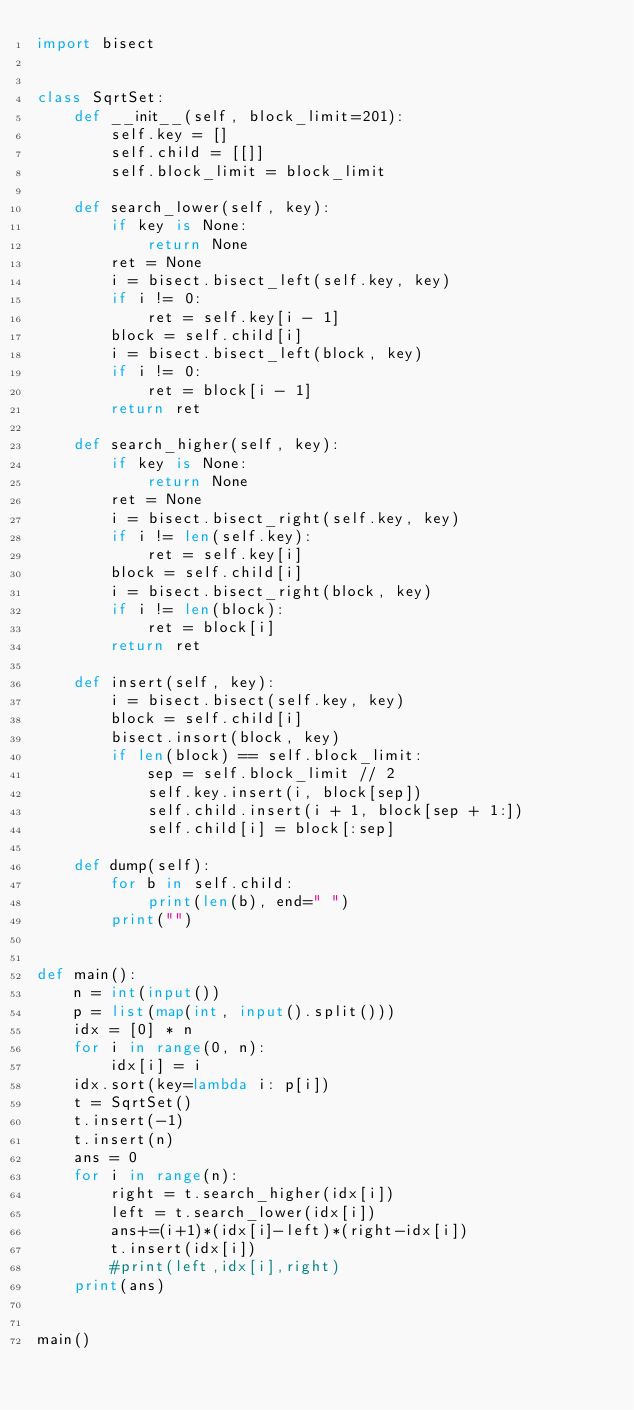<code> <loc_0><loc_0><loc_500><loc_500><_Python_>import bisect


class SqrtSet:
    def __init__(self, block_limit=201):
        self.key = []
        self.child = [[]]
        self.block_limit = block_limit

    def search_lower(self, key):
        if key is None:
            return None
        ret = None
        i = bisect.bisect_left(self.key, key)
        if i != 0:
            ret = self.key[i - 1]
        block = self.child[i]
        i = bisect.bisect_left(block, key)
        if i != 0:
            ret = block[i - 1]
        return ret
        
    def search_higher(self, key):
        if key is None:
            return None
        ret = None
        i = bisect.bisect_right(self.key, key)
        if i != len(self.key):
            ret = self.key[i]
        block = self.child[i]
        i = bisect.bisect_right(block, key)
        if i != len(block):
            ret = block[i]
        return ret

    def insert(self, key):
        i = bisect.bisect(self.key, key)
        block = self.child[i]
        bisect.insort(block, key)
        if len(block) == self.block_limit:
            sep = self.block_limit // 2
            self.key.insert(i, block[sep])
            self.child.insert(i + 1, block[sep + 1:])
            self.child[i] = block[:sep]
                
    def dump(self):
        for b in self.child:
            print(len(b), end=" ")
        print("")
            
            
def main():
    n = int(input())
    p = list(map(int, input().split()))
    idx = [0] * n
    for i in range(0, n):
        idx[i] = i
    idx.sort(key=lambda i: p[i])
    t = SqrtSet()
    t.insert(-1)
    t.insert(n)
    ans = 0
    for i in range(n):
        right = t.search_higher(idx[i])
        left = t.search_lower(idx[i])
        ans+=(i+1)*(idx[i]-left)*(right-idx[i])
        t.insert(idx[i])
        #print(left,idx[i],right)
    print(ans)


main()
</code> 